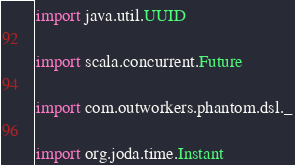Convert code to text. <code><loc_0><loc_0><loc_500><loc_500><_Scala_>import java.util.UUID

import scala.concurrent.Future

import com.outworkers.phantom.dsl._

import org.joda.time.Instant
</code> 